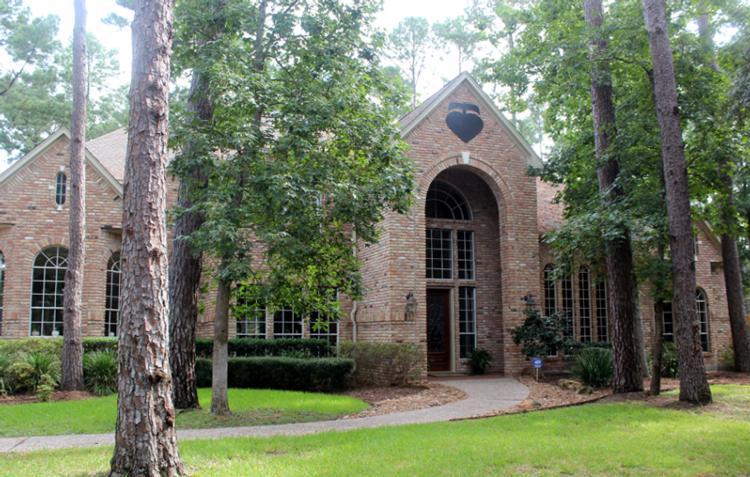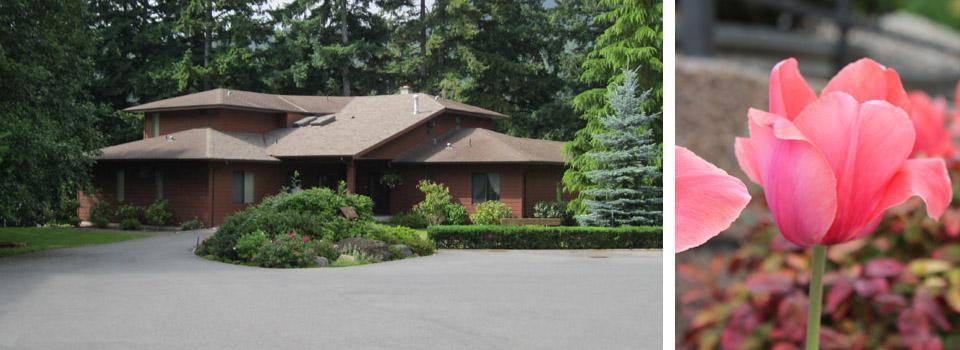The first image is the image on the left, the second image is the image on the right. Evaluate the accuracy of this statement regarding the images: "The house on the left has at least one arch shape around a window or door.". Is it true? Answer yes or no. Yes. 